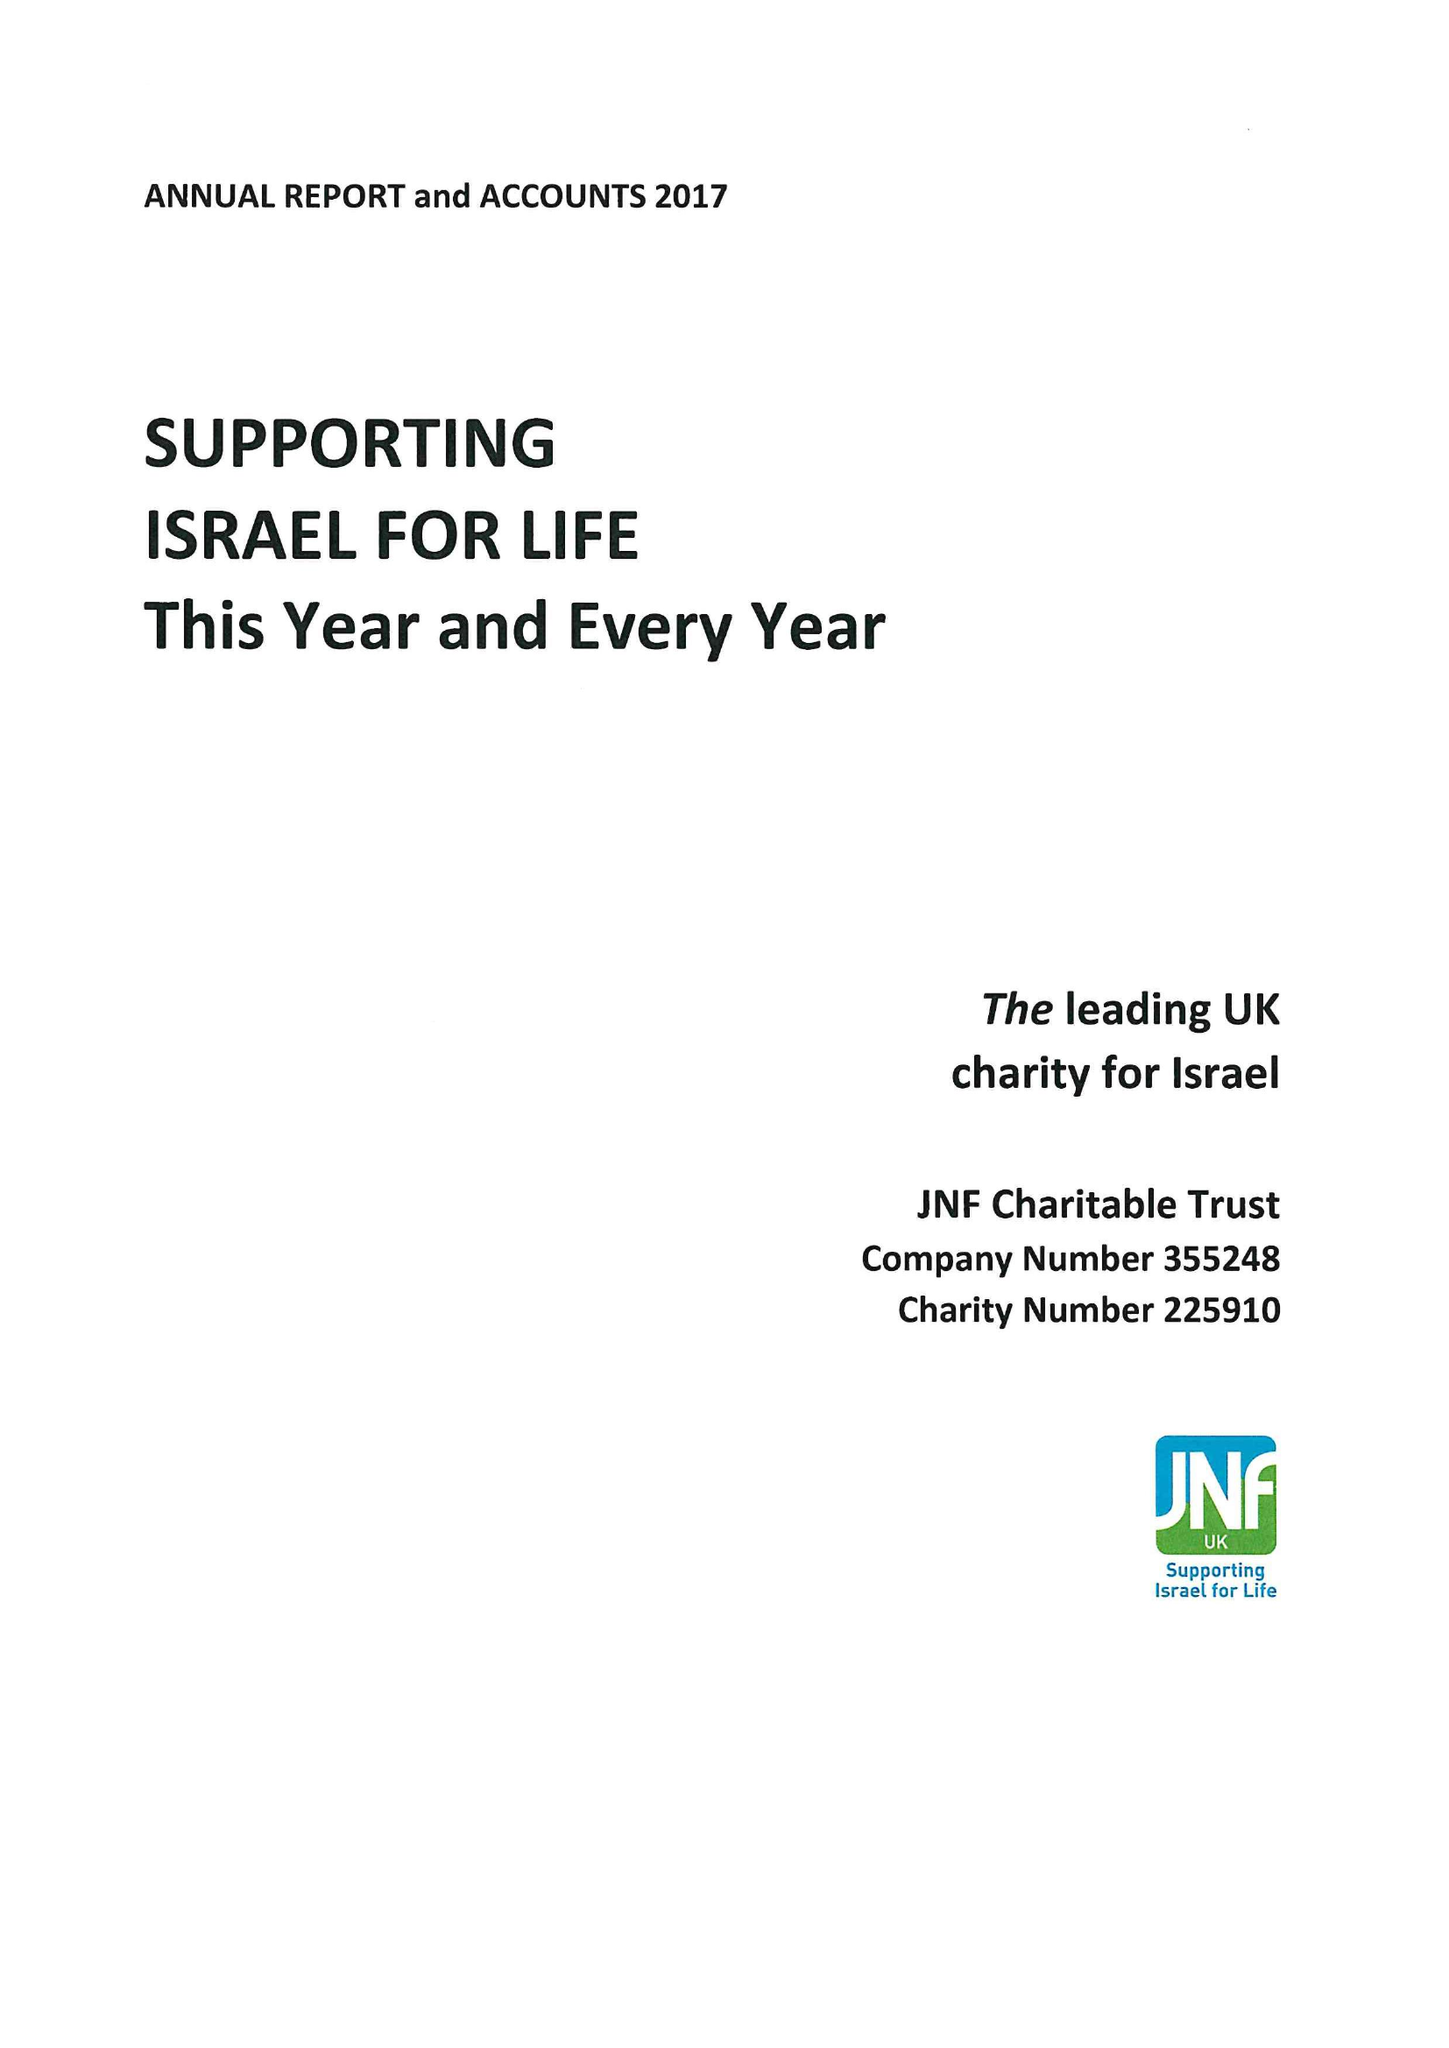What is the value for the address__postcode?
Answer the question using a single word or phrase. NW4 2BF 